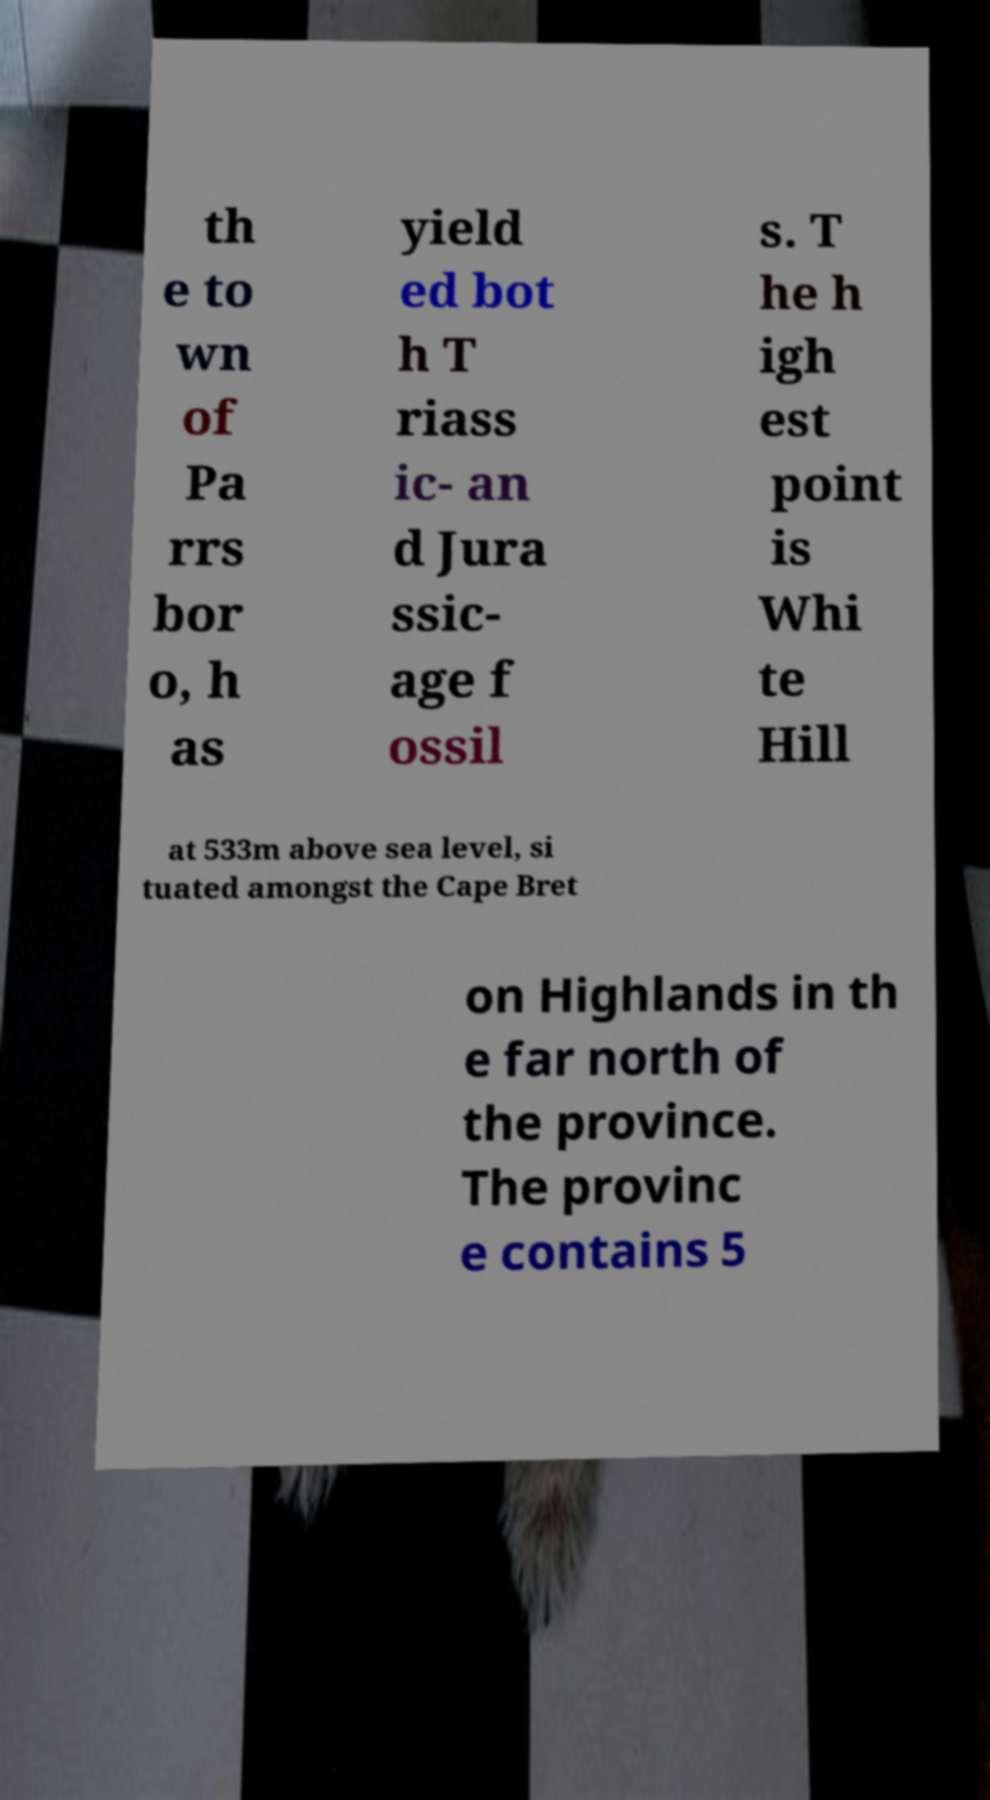Could you extract and type out the text from this image? th e to wn of Pa rrs bor o, h as yield ed bot h T riass ic- an d Jura ssic- age f ossil s. T he h igh est point is Whi te Hill at 533m above sea level, si tuated amongst the Cape Bret on Highlands in th e far north of the province. The provinc e contains 5 